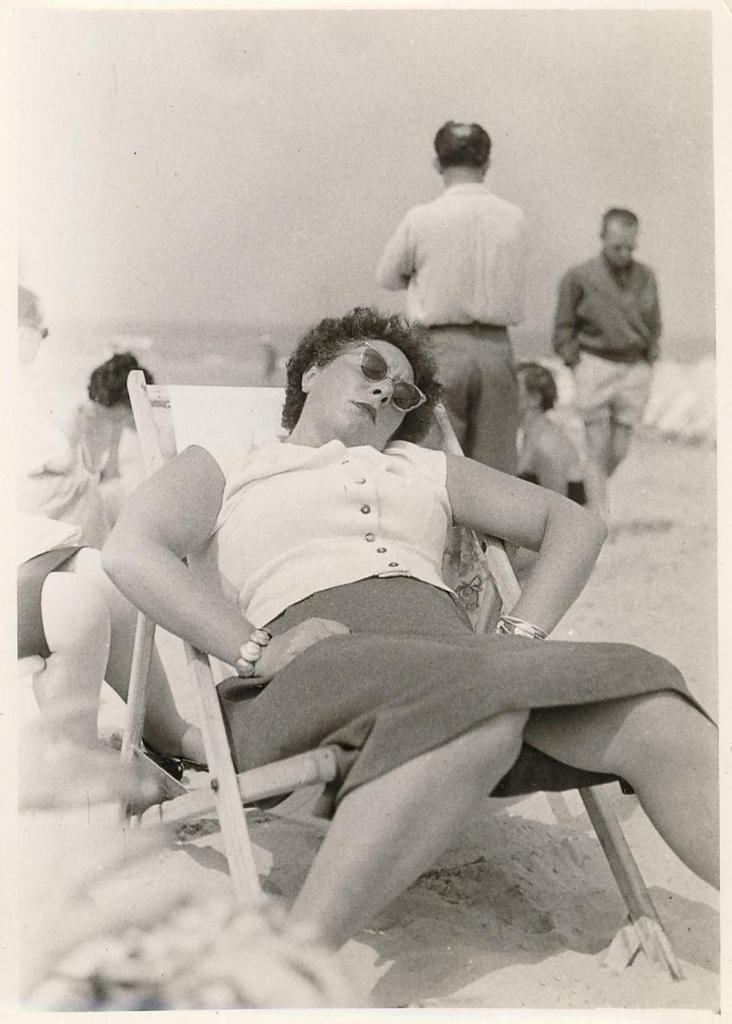What can be observed about the people in the image? There is a group of people in the image, with some seated and others walking. Can you describe the woman in the image? The woman is in the middle of the image and is wearing spectacles. What is the overall activity or setting of the image? The image shows a group of people, with some seated and others walking, but the specific context is not clear from the provided facts. What type of tin is being used by the people in the image? There is no tin present in the image; it features a group of people with some seated and others walking, along with a woman wearing spectacles. 